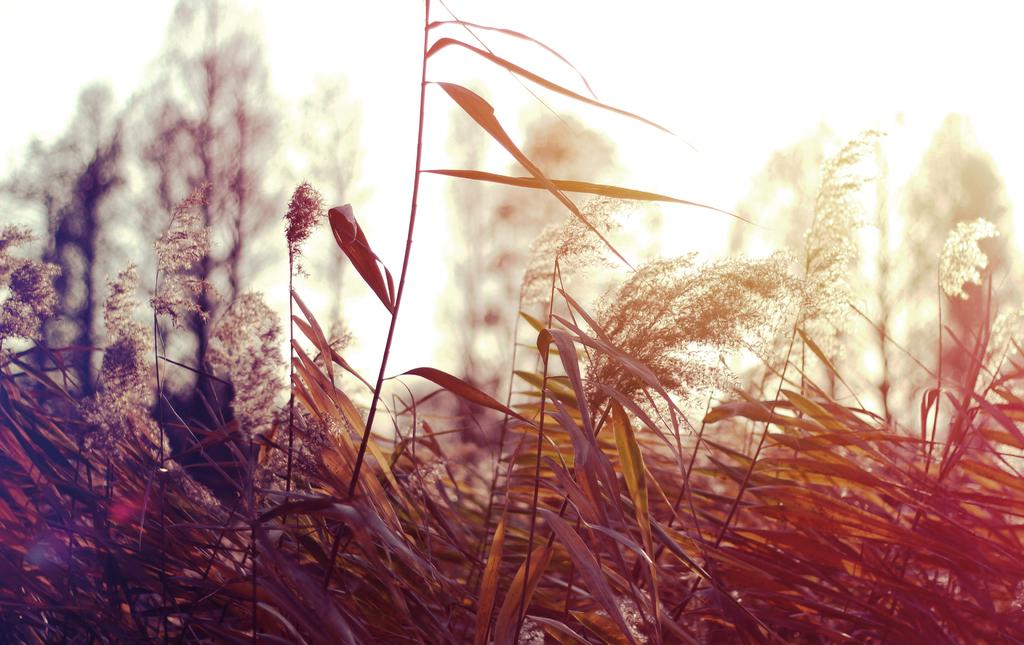What type of living organisms can be seen in the image? Plants can be seen in the image. What part of the natural environment is visible in the image? The sky is visible in the background of the image. How many rabbits can be seen hopping in the image? There are no rabbits present in the image. What type of breath is visible coming from the plants in the image? Plants do not have the ability to breathe, so there is no breath visible in the image. 